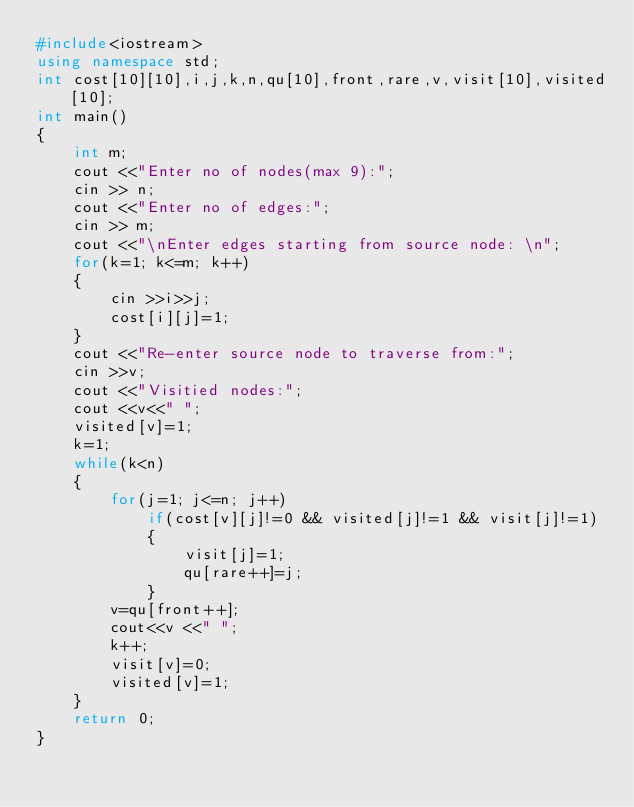<code> <loc_0><loc_0><loc_500><loc_500><_C++_>#include<iostream>
using namespace std;
int cost[10][10],i,j,k,n,qu[10],front,rare,v,visit[10],visited[10];
int main()
{
    int m;
    cout <<"Enter no of nodes(max 9):";
    cin >> n;
    cout <<"Enter no of edges:";
    cin >> m;
    cout <<"\nEnter edges starting from source node: \n";
    for(k=1; k<=m; k++)
    {
        cin >>i>>j;
        cost[i][j]=1;
    }
    cout <<"Re-enter source node to traverse from:";
    cin >>v;
    cout <<"Visitied nodes:";
    cout <<v<<" ";
    visited[v]=1;
    k=1;
    while(k<n)
    {
        for(j=1; j<=n; j++)
            if(cost[v][j]!=0 && visited[j]!=1 && visit[j]!=1)
            {
                visit[j]=1;
                qu[rare++]=j;
            }
        v=qu[front++];
        cout<<v <<" ";
        k++;
        visit[v]=0;
        visited[v]=1;
    }
    return 0;
}
</code> 